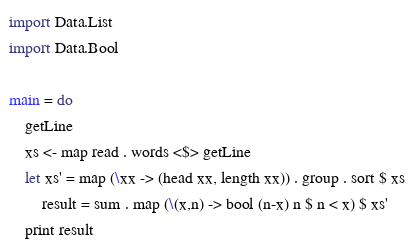Convert code to text. <code><loc_0><loc_0><loc_500><loc_500><_Haskell_>import Data.List
import Data.Bool

main = do
    getLine
    xs <- map read . words <$> getLine
    let xs' = map (\xx -> (head xx, length xx)) . group . sort $ xs
        result = sum . map (\(x,n) -> bool (n-x) n $ n < x) $ xs'
    print result
</code> 